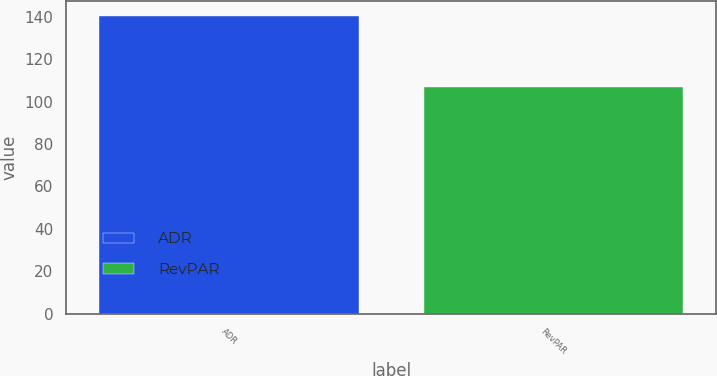Convert chart to OTSL. <chart><loc_0><loc_0><loc_500><loc_500><bar_chart><fcel>ADR<fcel>RevPAR<nl><fcel>140.31<fcel>106.89<nl></chart> 